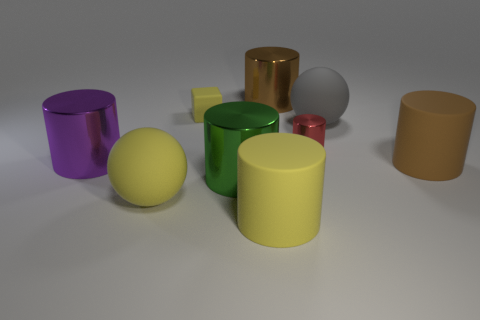There is a cube; what number of purple things are to the right of it?
Provide a short and direct response. 0. The red metal cylinder has what size?
Your answer should be compact. Small. Is the material of the big brown cylinder that is on the left side of the gray rubber ball the same as the yellow object that is behind the brown matte object?
Your answer should be very brief. No. Is there a rubber thing of the same color as the tiny metal cylinder?
Keep it short and to the point. No. There is a cube that is the same size as the red metallic cylinder; what is its color?
Offer a very short reply. Yellow. Do the rubber sphere that is in front of the green cylinder and the small cube have the same color?
Give a very brief answer. Yes. Is there another ball that has the same material as the large yellow sphere?
Make the answer very short. Yes. Is the number of tiny matte blocks that are in front of the purple metal cylinder less than the number of red metal objects?
Provide a short and direct response. Yes. There is a yellow matte object behind the red metal thing; does it have the same size as the large brown matte thing?
Your answer should be compact. No. What number of other tiny red metallic objects have the same shape as the red metallic object?
Give a very brief answer. 0. 